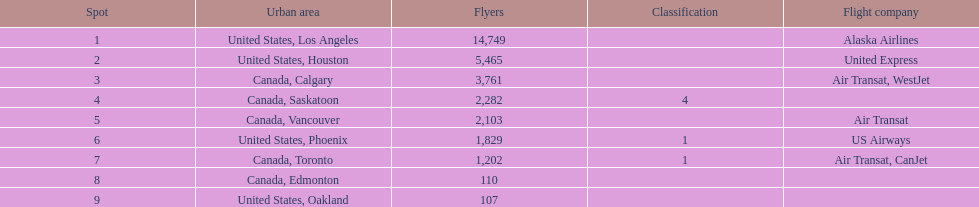How many airlines have a steady ranking? 4. 